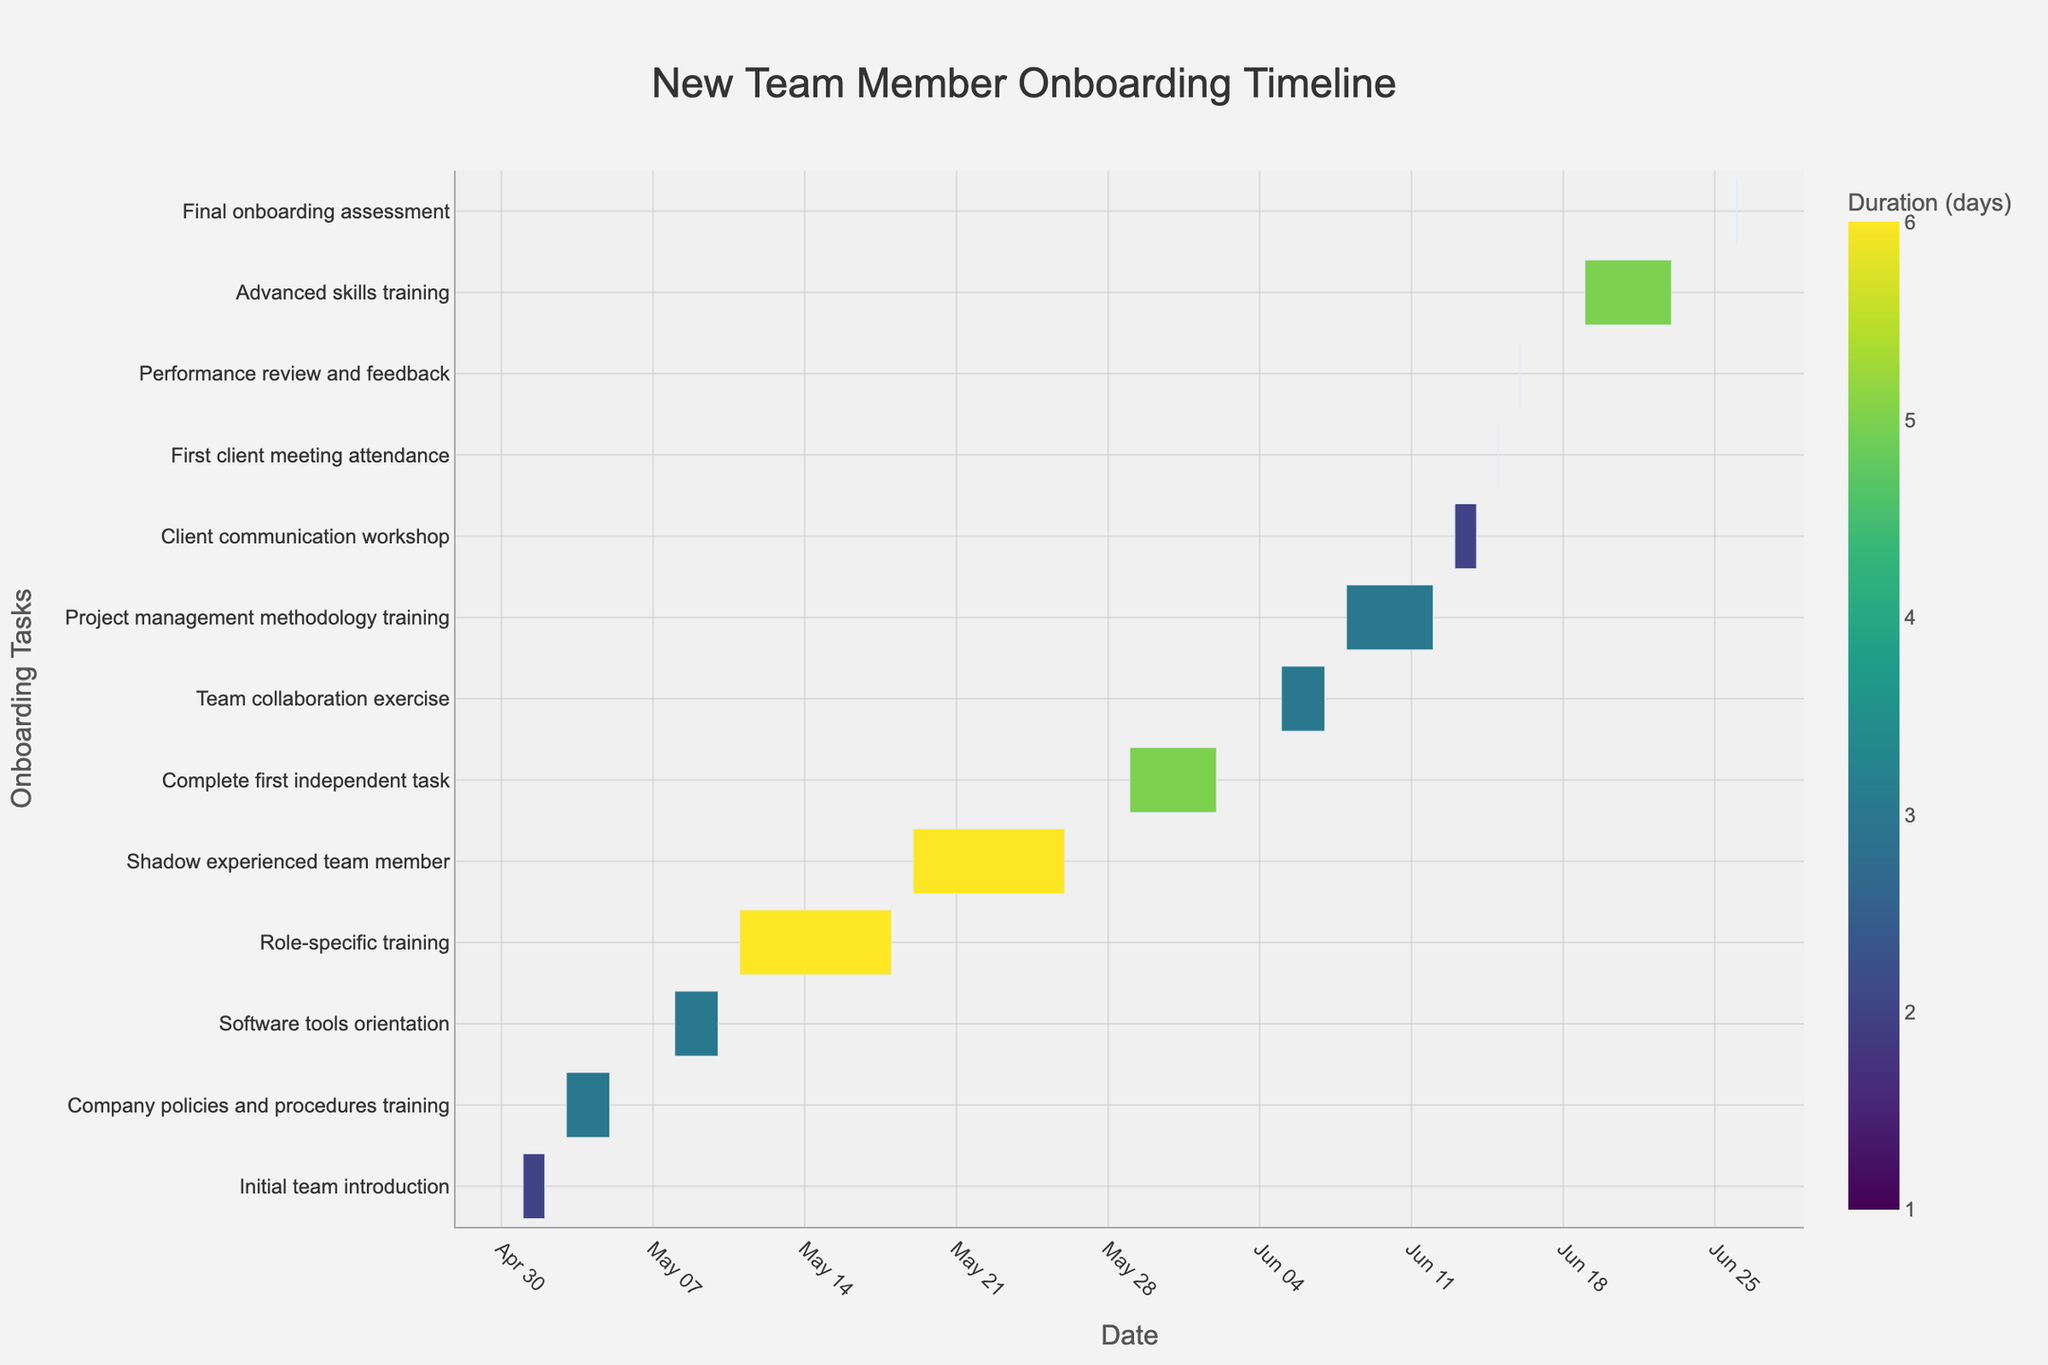What's the title of the Gantt chart? The title is located at the top of the figure in a prominent position. The title helps in understanding the context and purpose of the Gantt chart.
Answer: New Team Member Onboarding Timeline What are the start and end dates for the Role-specific training? Locate the bar corresponding to "Role-specific training" on the y-axis, then identify the start and end points on the x-axis.
Answer: Start: 2023-05-11, End: 2023-05-18 Which task has the shortest duration? Identify the shortest bar on the Gantt chart by examining the length of each task bar on the x-axis.
Answer: First client meeting attendance, Performance review and feedback, Final onboarding assessment How many tasks are included in the onboarding process? Count the number of unique tasks listed on the y-axis of the Gantt chart.
Answer: 13 Which task spans the longest duration and what is it? Compare the length of each task bar on the Gantt chart and identify the longest one by its length on the x-axis.
Answer: Role-specific training, Shadow experienced team member What are the start and end dates for the entire onboarding process? Examine the earliest start date and the latest end date across all tasks on the x-axis.
Answer: Start: 2023-05-01, End: 2023-06-26 How does the duration of the Software tools orientation compare with the Company policies and procedures training? Find the bars for these two tasks and compare their lengths visually on the x-axis to determine which is longer.
Answer: Both have the same duration of 3 days Which tasks overlap with the Advanced skills training? Locate the "Advanced skills training" bar and check which other task bars intersect with its duration on the x-axis.
Answer: None 